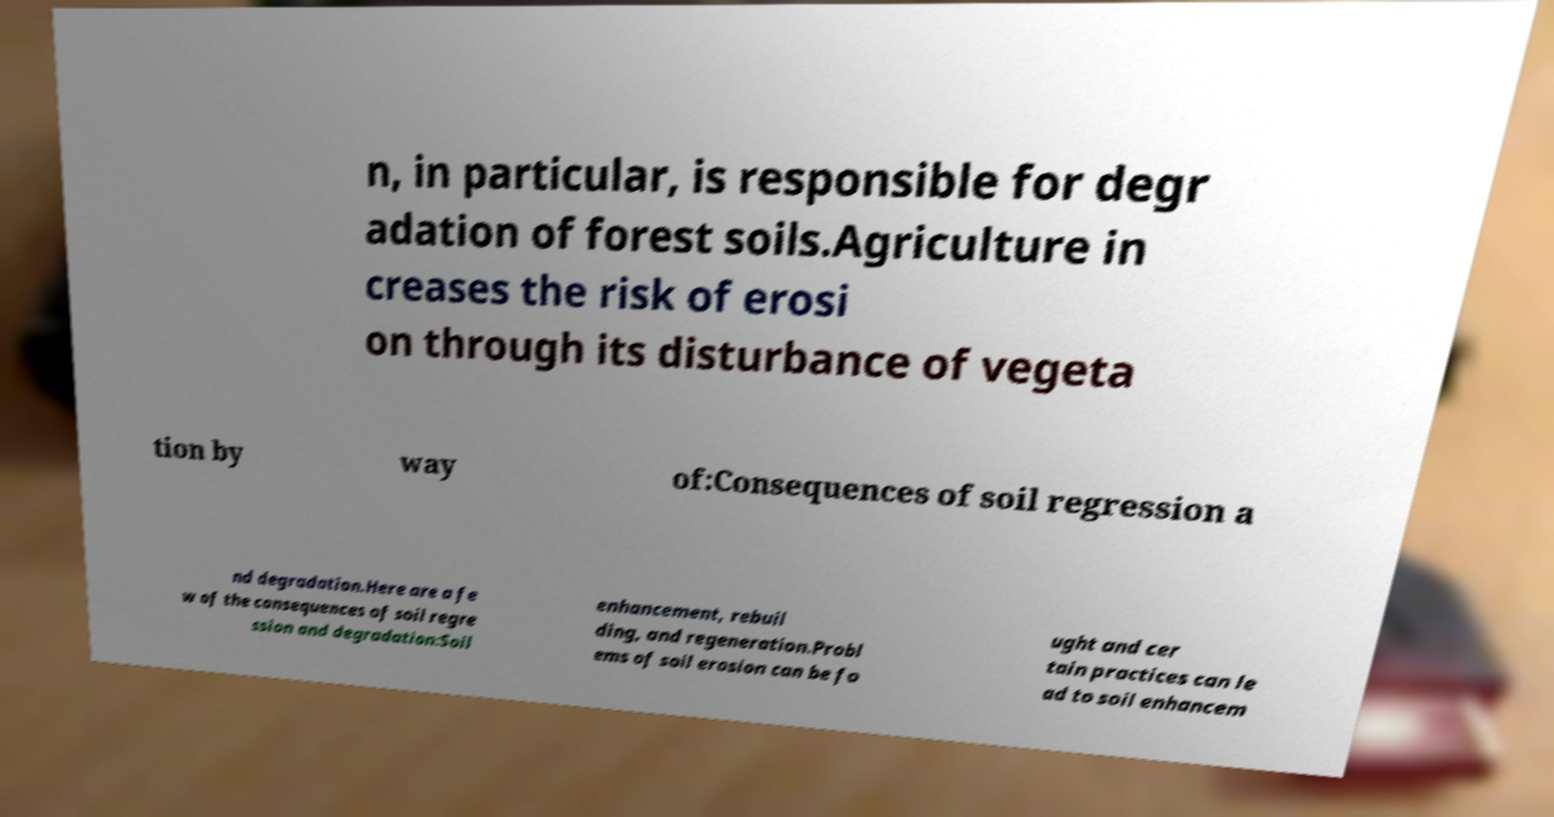There's text embedded in this image that I need extracted. Can you transcribe it verbatim? n, in particular, is responsible for degr adation of forest soils.Agriculture in creases the risk of erosi on through its disturbance of vegeta tion by way of:Consequences of soil regression a nd degradation.Here are a fe w of the consequences of soil regre ssion and degradation:Soil enhancement, rebuil ding, and regeneration.Probl ems of soil erosion can be fo ught and cer tain practices can le ad to soil enhancem 